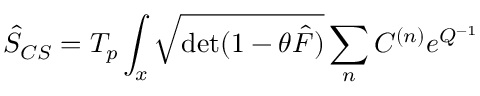<formula> <loc_0><loc_0><loc_500><loc_500>\hat { S } _ { C S } = T _ { p } \int _ { x } { \sqrt { d e t ( 1 - \theta \hat { F } ) } } \sum _ { n } C ^ { ( n ) } e ^ { Q ^ { - 1 } }</formula> 